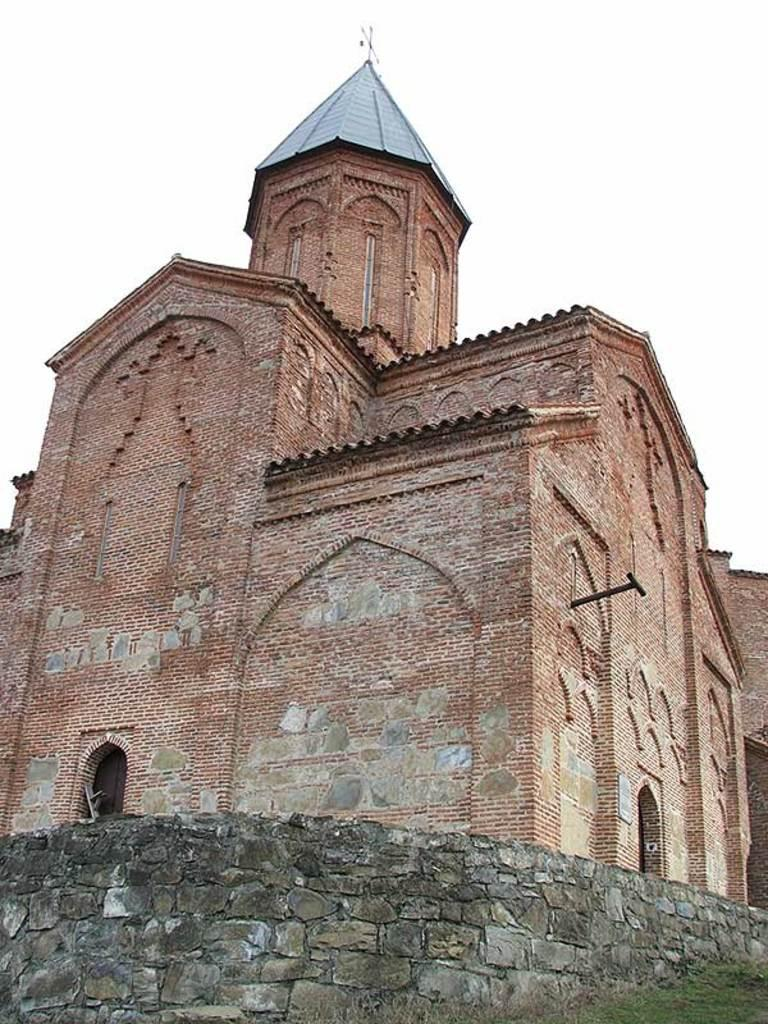What type of structure is present in the image? There is a building in the image. What feature of the building is mentioned in the facts? The building has doors. What type of vegetation is visible in the image? There is grass in the image. What other architectural element is present in the image? There is a wall in the image. What can be seen in the background of the image? The sky is visible in the background of the image. What type of quill is being used to write on the wall in the image? There is no quill or writing present on the wall in the image. What trick is being performed by the building in the image? There is no trick being performed by the building in the image; it is a stationary structure. 